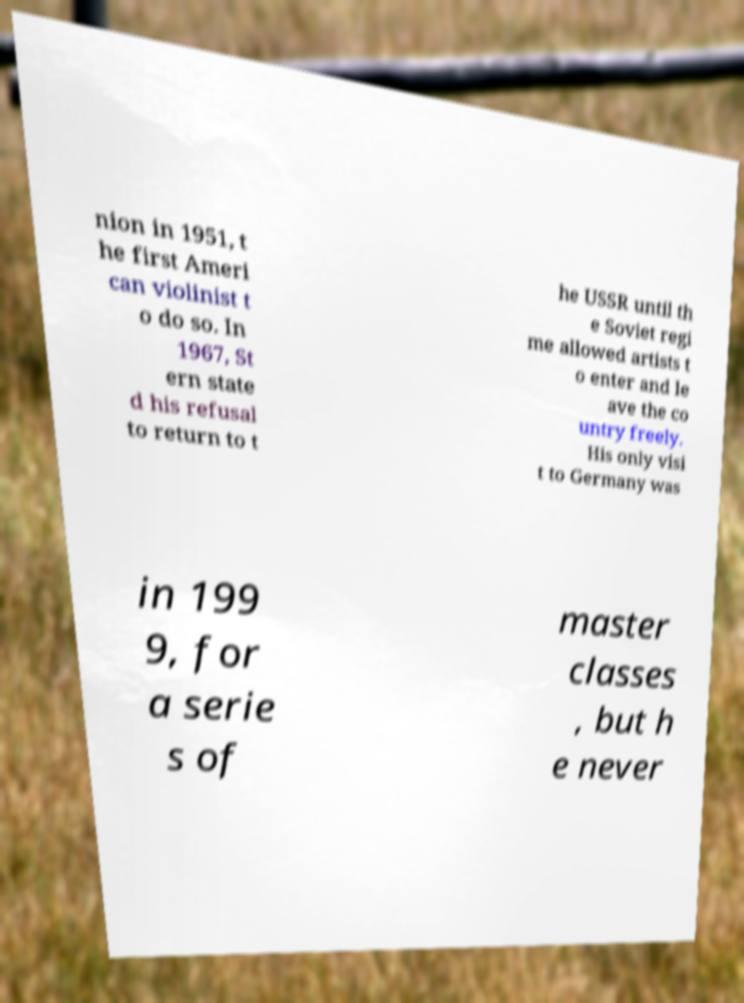What messages or text are displayed in this image? I need them in a readable, typed format. nion in 1951, t he first Ameri can violinist t o do so. In 1967, St ern state d his refusal to return to t he USSR until th e Soviet regi me allowed artists t o enter and le ave the co untry freely. His only visi t to Germany was in 199 9, for a serie s of master classes , but h e never 